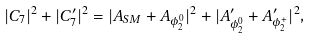<formula> <loc_0><loc_0><loc_500><loc_500>| C _ { 7 } | ^ { 2 } + | C ^ { \prime } _ { 7 } | ^ { 2 } = | A _ { S M } + A _ { \phi _ { 2 } ^ { 0 } } | ^ { 2 } + | A ^ { \prime } _ { \phi _ { 2 } ^ { 0 } } + A ^ { \prime } _ { \phi _ { 2 } ^ { + } } | ^ { 2 } ,</formula> 